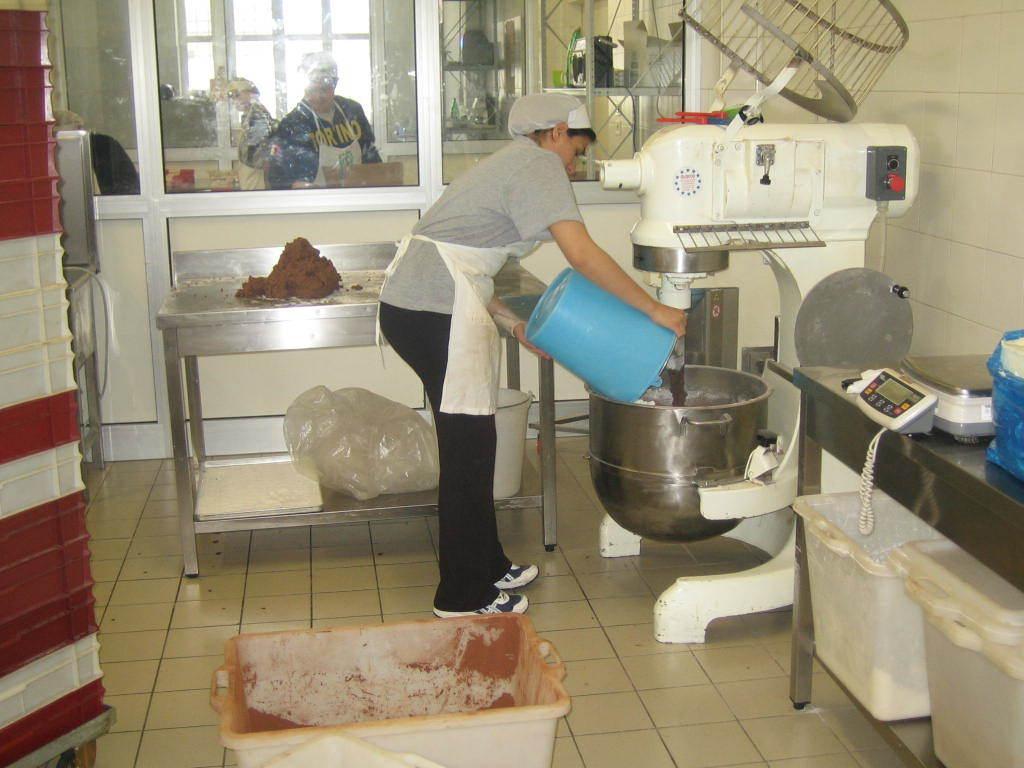In one or two sentences, can you explain what this image depicts? a tube is present on the floor. behind that a person is standing wearing apron, holding a bucket in his hand. in front of him a machine present. behind him there is a table, under which there is a cover. at the right front there are tubs. above the table there is a weighing machine. 